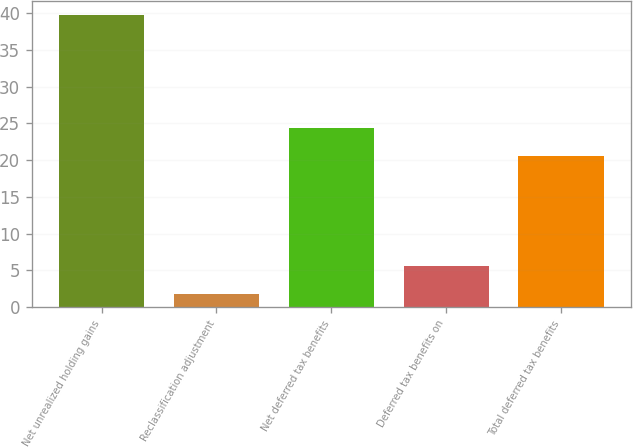<chart> <loc_0><loc_0><loc_500><loc_500><bar_chart><fcel>Net unrealized holding gains<fcel>Reclassification adjustment<fcel>Net deferred tax benefits<fcel>Deferred tax benefits on<fcel>Total deferred tax benefits<nl><fcel>39.7<fcel>1.8<fcel>24.39<fcel>5.59<fcel>20.6<nl></chart> 